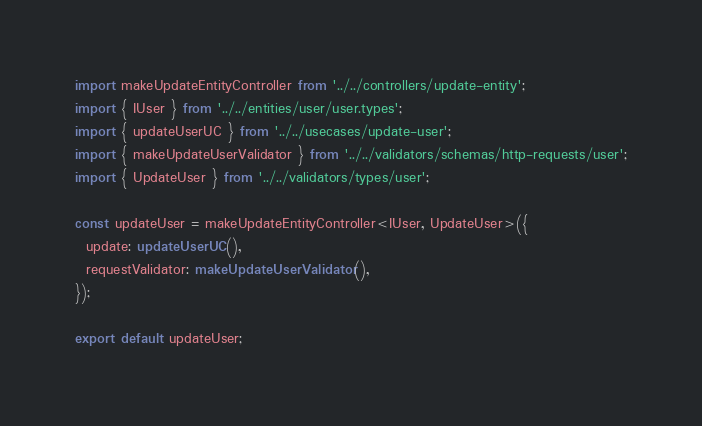<code> <loc_0><loc_0><loc_500><loc_500><_TypeScript_>import makeUpdateEntityController from '../../controllers/update-entity';
import { IUser } from '../../entities/user/user.types';
import { updateUserUC } from '../../usecases/update-user';
import { makeUpdateUserValidator } from '../../validators/schemas/http-requests/user';
import { UpdateUser } from '../../validators/types/user';

const updateUser = makeUpdateEntityController<IUser, UpdateUser>({
  update: updateUserUC(),
  requestValidator: makeUpdateUserValidator(),
});

export default updateUser;
</code> 